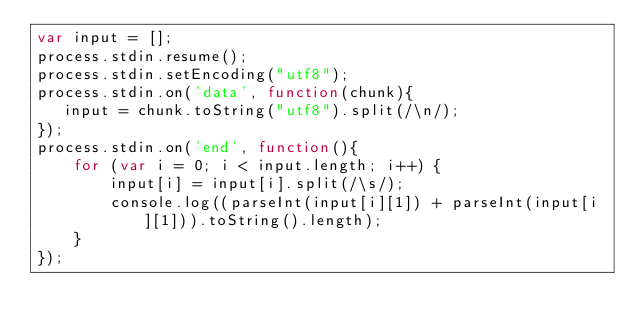Convert code to text. <code><loc_0><loc_0><loc_500><loc_500><_JavaScript_>var input = [];
process.stdin.resume();
process.stdin.setEncoding("utf8");
process.stdin.on('data', function(chunk){
   input = chunk.toString("utf8").split(/\n/);
});
process.stdin.on('end', function(){
    for (var i = 0; i < input.length; i++) {
        input[i] = input[i].split(/\s/);
        console.log((parseInt(input[i][1]) + parseInt(input[i][1])).toString().length);
    }
});</code> 